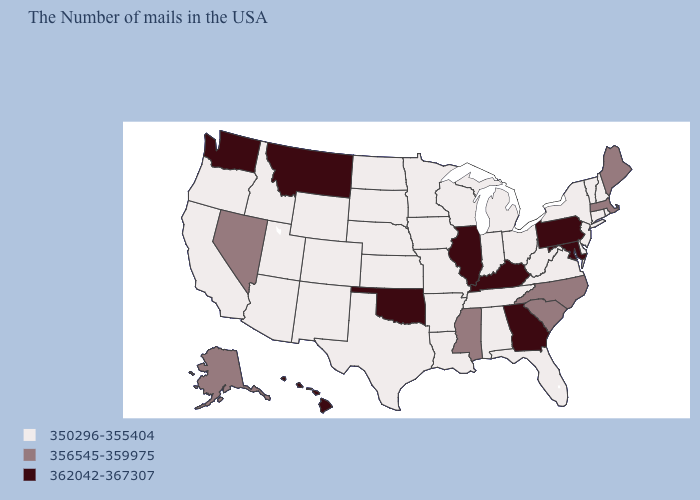What is the value of Florida?
Answer briefly. 350296-355404. Which states have the lowest value in the West?
Concise answer only. Wyoming, Colorado, New Mexico, Utah, Arizona, Idaho, California, Oregon. Name the states that have a value in the range 350296-355404?
Short answer required. Rhode Island, New Hampshire, Vermont, Connecticut, New York, New Jersey, Delaware, Virginia, West Virginia, Ohio, Florida, Michigan, Indiana, Alabama, Tennessee, Wisconsin, Louisiana, Missouri, Arkansas, Minnesota, Iowa, Kansas, Nebraska, Texas, South Dakota, North Dakota, Wyoming, Colorado, New Mexico, Utah, Arizona, Idaho, California, Oregon. Among the states that border Virginia , which have the highest value?
Concise answer only. Maryland, Kentucky. What is the value of Washington?
Keep it brief. 362042-367307. Name the states that have a value in the range 362042-367307?
Keep it brief. Maryland, Pennsylvania, Georgia, Kentucky, Illinois, Oklahoma, Montana, Washington, Hawaii. What is the value of Tennessee?
Concise answer only. 350296-355404. Which states have the lowest value in the South?
Keep it brief. Delaware, Virginia, West Virginia, Florida, Alabama, Tennessee, Louisiana, Arkansas, Texas. Name the states that have a value in the range 356545-359975?
Short answer required. Maine, Massachusetts, North Carolina, South Carolina, Mississippi, Nevada, Alaska. Name the states that have a value in the range 362042-367307?
Quick response, please. Maryland, Pennsylvania, Georgia, Kentucky, Illinois, Oklahoma, Montana, Washington, Hawaii. What is the value of Montana?
Keep it brief. 362042-367307. What is the lowest value in states that border New Jersey?
Concise answer only. 350296-355404. Name the states that have a value in the range 350296-355404?
Keep it brief. Rhode Island, New Hampshire, Vermont, Connecticut, New York, New Jersey, Delaware, Virginia, West Virginia, Ohio, Florida, Michigan, Indiana, Alabama, Tennessee, Wisconsin, Louisiana, Missouri, Arkansas, Minnesota, Iowa, Kansas, Nebraska, Texas, South Dakota, North Dakota, Wyoming, Colorado, New Mexico, Utah, Arizona, Idaho, California, Oregon. Name the states that have a value in the range 356545-359975?
Give a very brief answer. Maine, Massachusetts, North Carolina, South Carolina, Mississippi, Nevada, Alaska. 